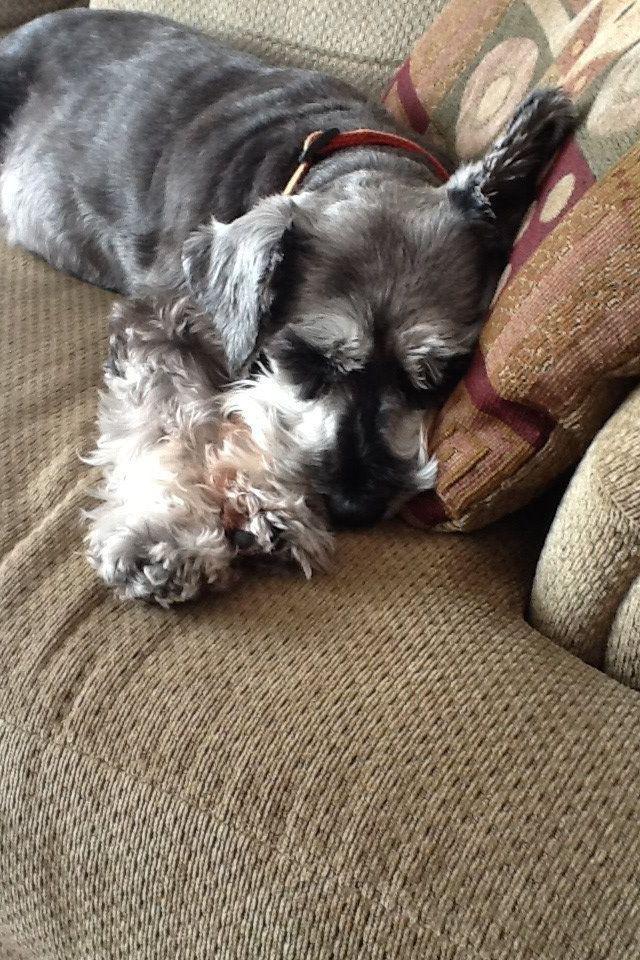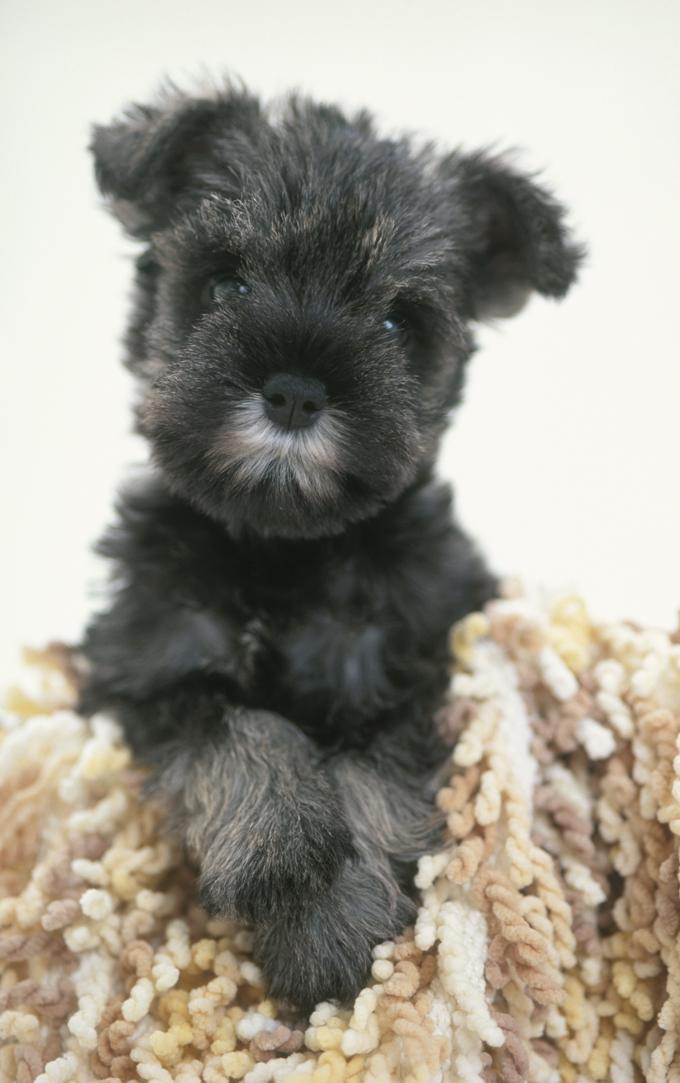The first image is the image on the left, the second image is the image on the right. Analyze the images presented: Is the assertion "One dog is asleep, while another dog is awake." valid? Answer yes or no. Yes. The first image is the image on the left, the second image is the image on the right. Examine the images to the left and right. Is the description "Each image shows just one dog, and one is lying down, while the other has an upright head and open eyes." accurate? Answer yes or no. Yes. 